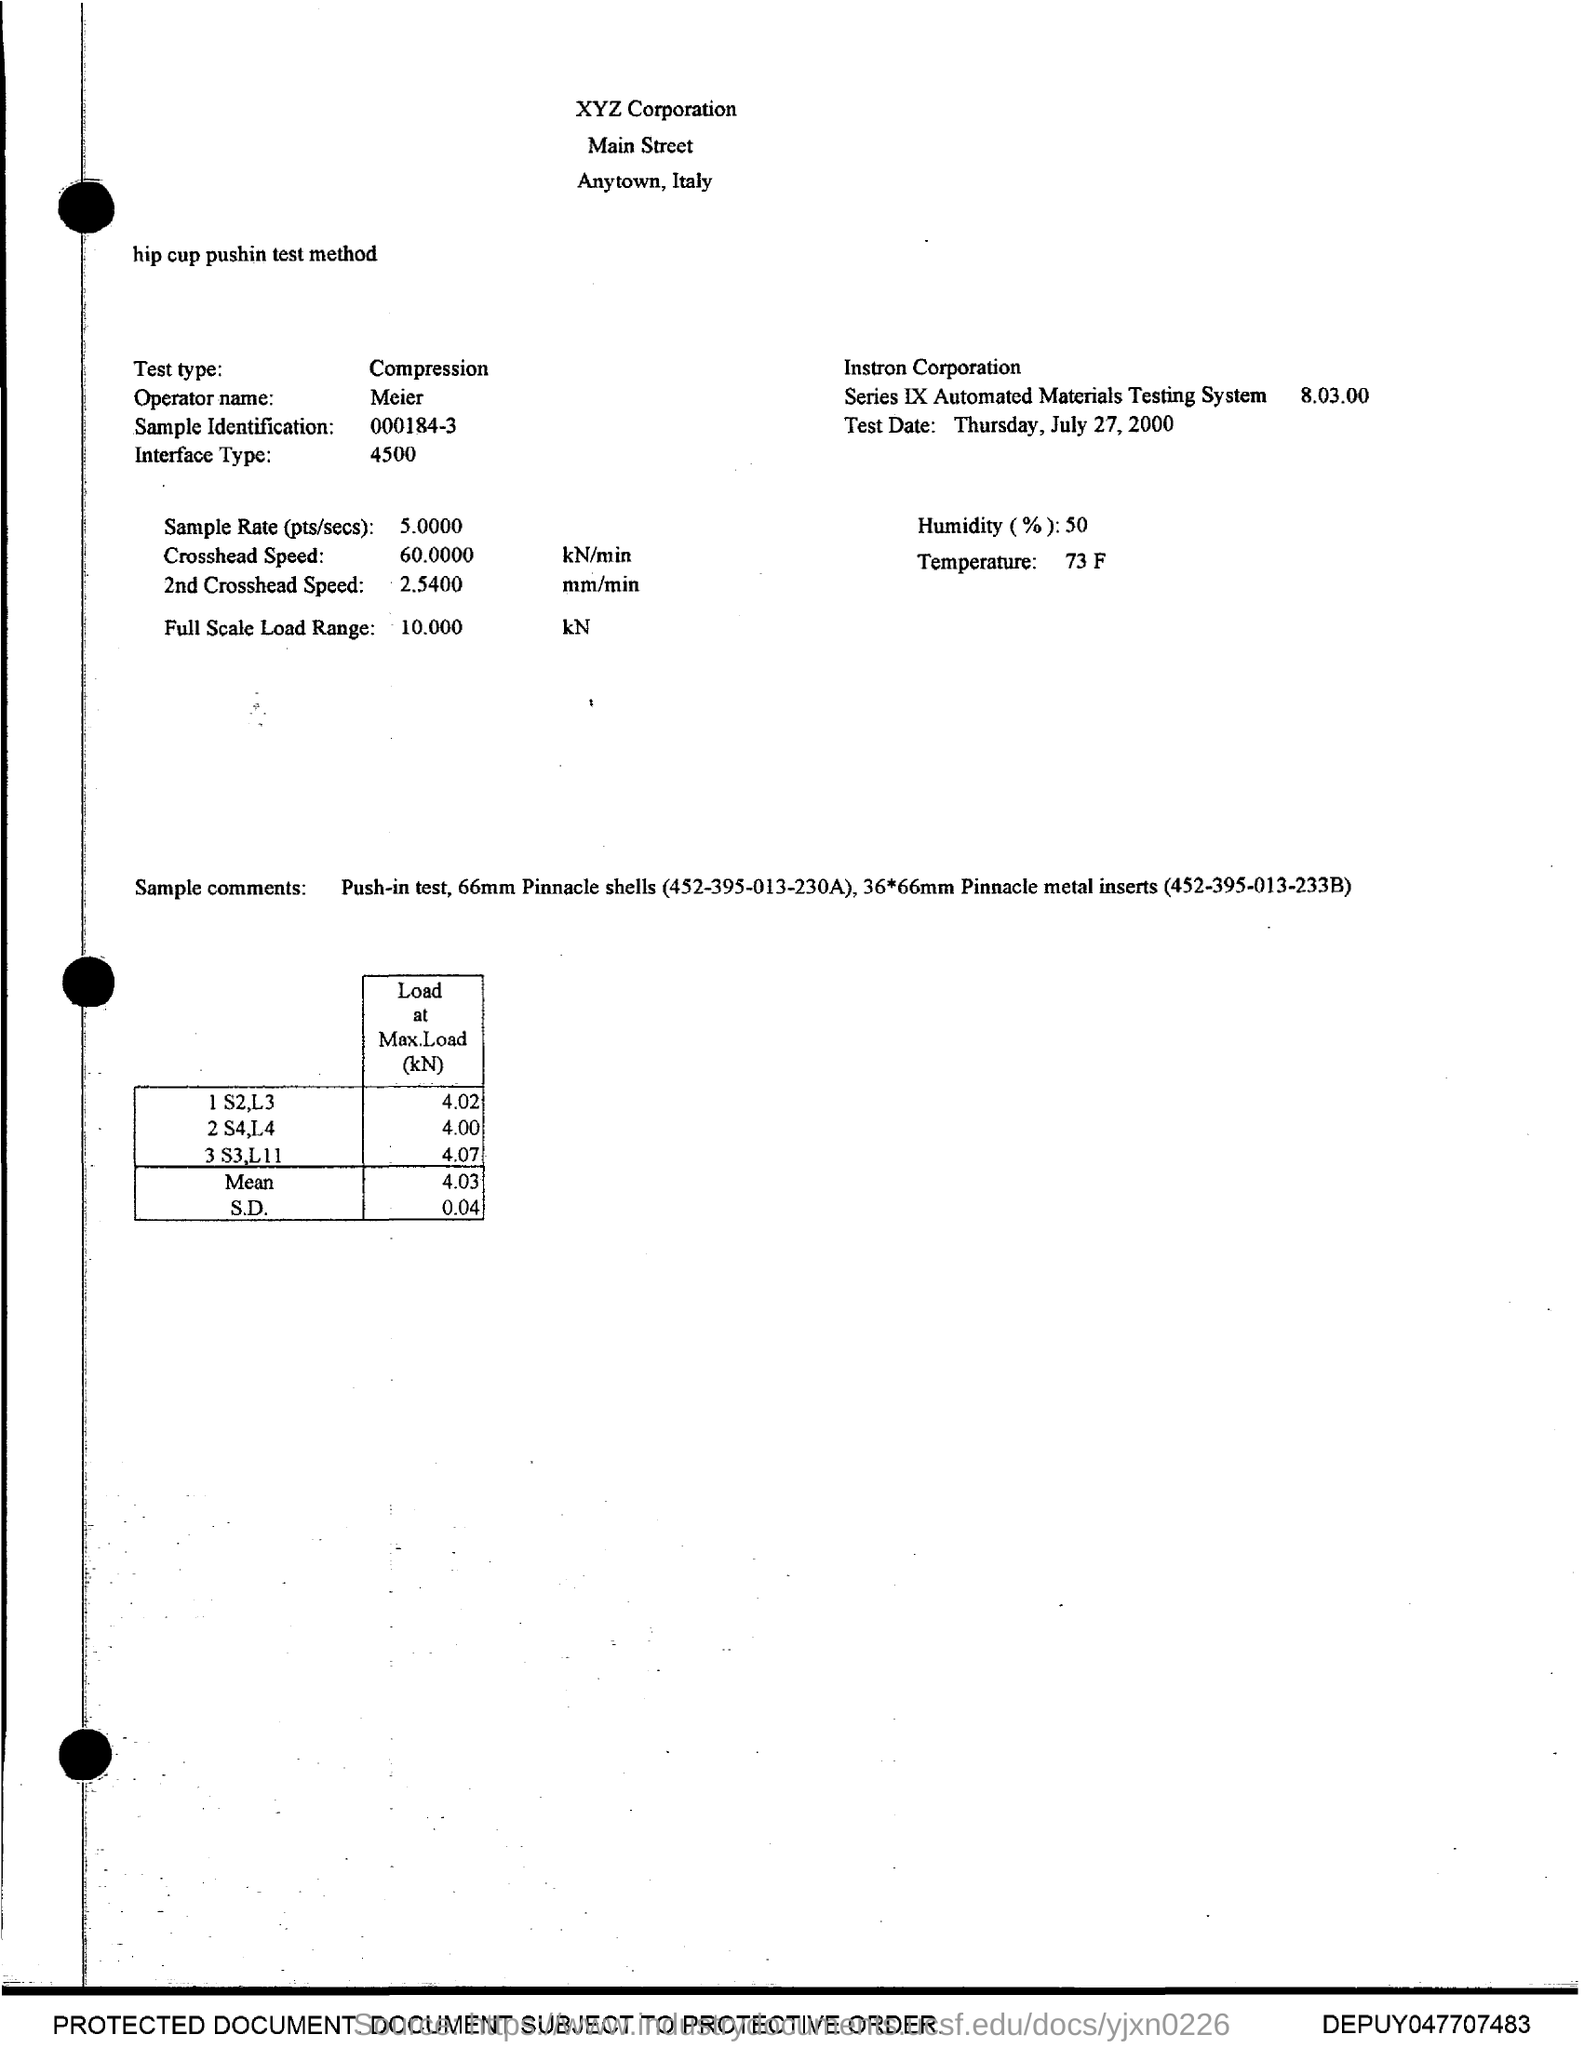Point out several critical features in this image. The test type is compression. The current humidity level is 50%. The temperature is 73 Fahrenheit. The Operator's name is Meier. 